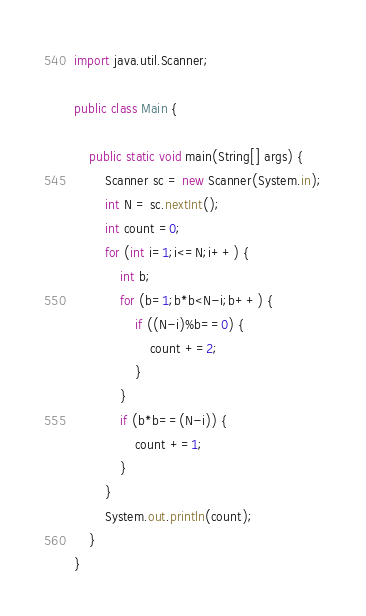<code> <loc_0><loc_0><loc_500><loc_500><_Java_>import java.util.Scanner;

public class Main {

	public static void main(String[] args) {
		Scanner sc = new Scanner(System.in);
		int N = sc.nextInt();
		int count =0;
		for (int i=1;i<=N;i++) {
			int b;
			for (b=1;b*b<N-i;b++) {
				if ((N-i)%b==0) {
					count +=2;
				}
			}
			if (b*b==(N-i)) {
				count +=1;
			}
		}
		System.out.println(count);
	}
}
</code> 